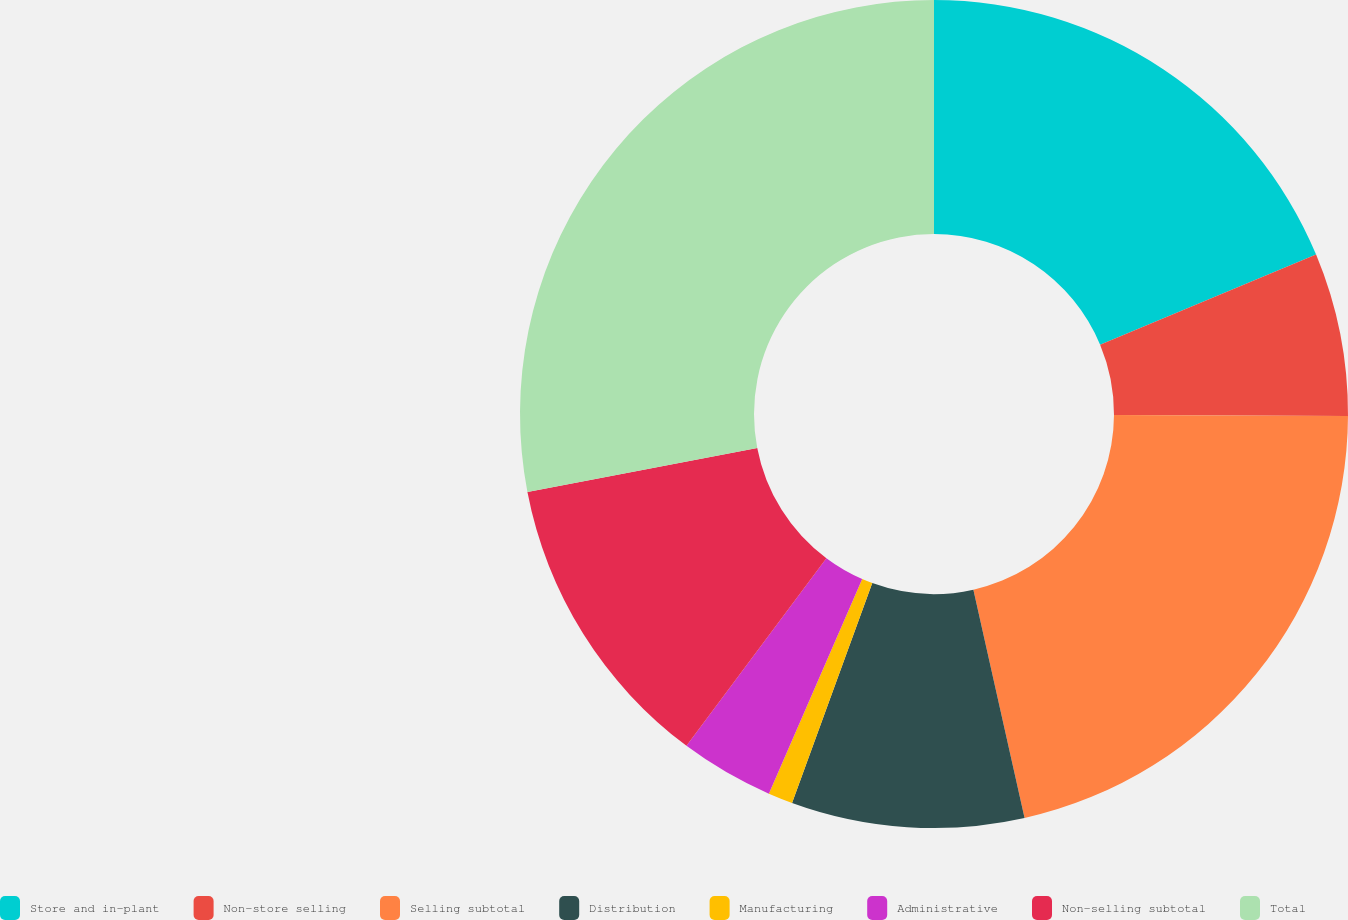Convert chart. <chart><loc_0><loc_0><loc_500><loc_500><pie_chart><fcel>Store and in-plant<fcel>Non-store selling<fcel>Selling subtotal<fcel>Distribution<fcel>Manufacturing<fcel>Administrative<fcel>Non-selling subtotal<fcel>Total<nl><fcel>18.71%<fcel>6.37%<fcel>21.41%<fcel>9.08%<fcel>0.96%<fcel>3.67%<fcel>11.78%<fcel>28.02%<nl></chart> 